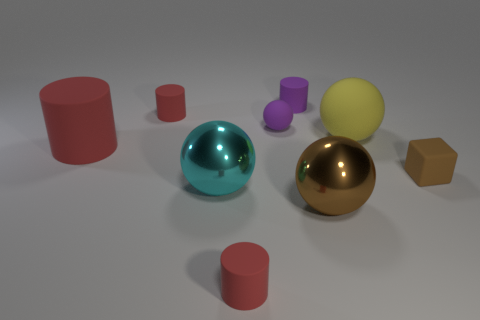Subtract all purple cylinders. How many cylinders are left? 3 Subtract all gray cubes. How many red cylinders are left? 3 Subtract all purple cylinders. How many cylinders are left? 3 Subtract all gray cylinders. Subtract all green blocks. How many cylinders are left? 4 Add 1 purple matte cylinders. How many objects exist? 10 Subtract all spheres. How many objects are left? 5 Subtract all tiny brown matte spheres. Subtract all tiny matte cylinders. How many objects are left? 6 Add 1 small brown rubber cubes. How many small brown rubber cubes are left? 2 Add 3 brown shiny balls. How many brown shiny balls exist? 4 Subtract 1 purple cylinders. How many objects are left? 8 